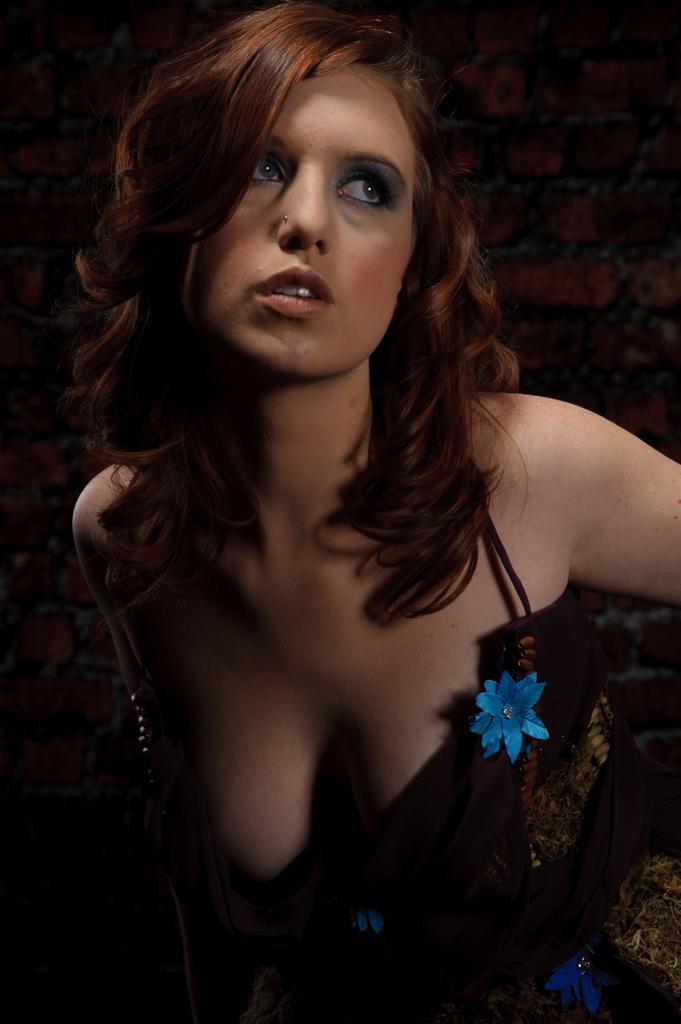Can you describe this image briefly? In this image, we can see a lady. In the background, we can see the brick wall. 